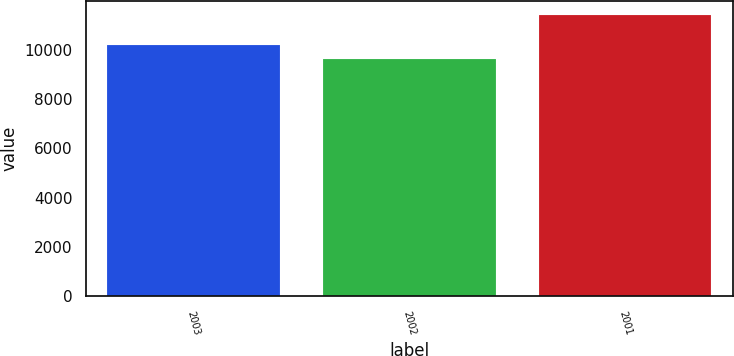Convert chart. <chart><loc_0><loc_0><loc_500><loc_500><bar_chart><fcel>2003<fcel>2002<fcel>2001<nl><fcel>10186<fcel>9625<fcel>11426<nl></chart> 